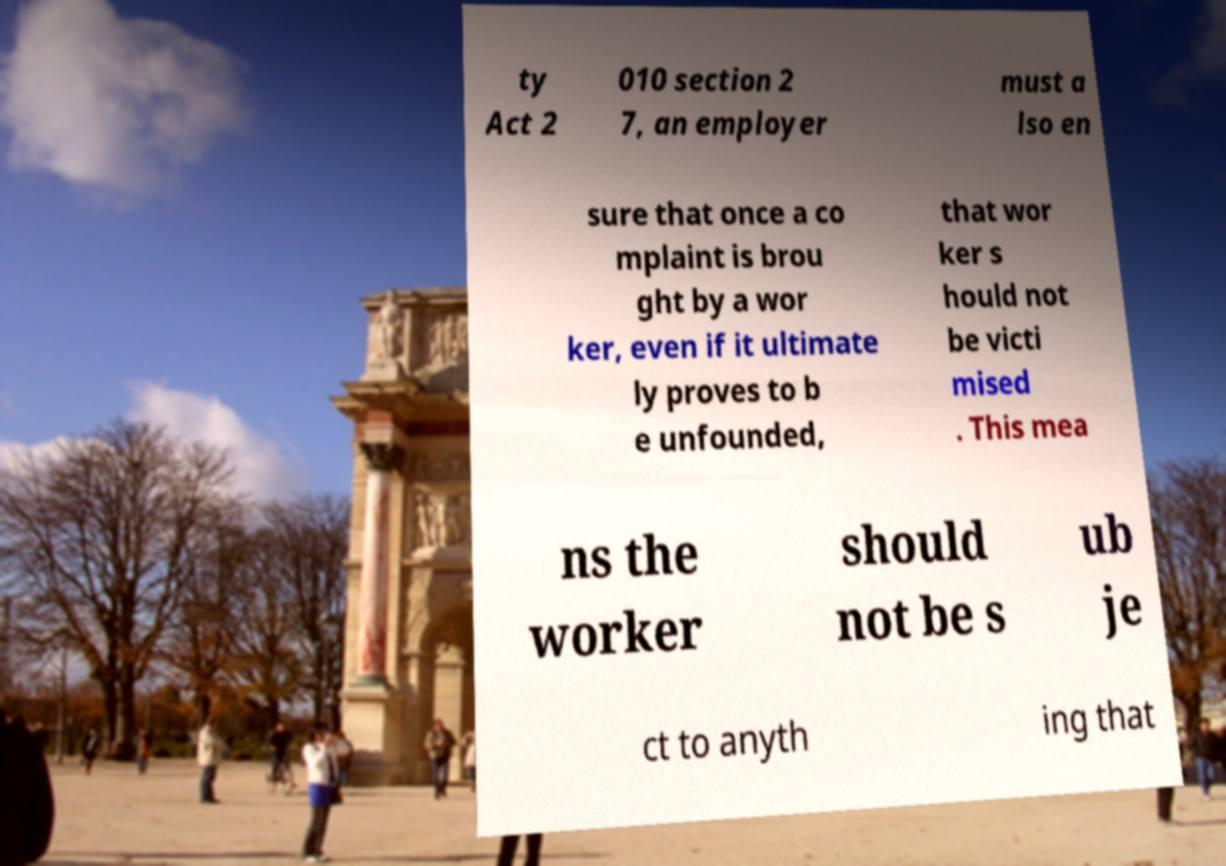Could you extract and type out the text from this image? ty Act 2 010 section 2 7, an employer must a lso en sure that once a co mplaint is brou ght by a wor ker, even if it ultimate ly proves to b e unfounded, that wor ker s hould not be victi mised . This mea ns the worker should not be s ub je ct to anyth ing that 